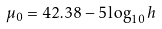<formula> <loc_0><loc_0><loc_500><loc_500>\mu _ { 0 } = 4 2 . 3 8 - 5 \log _ { 1 0 } h</formula> 